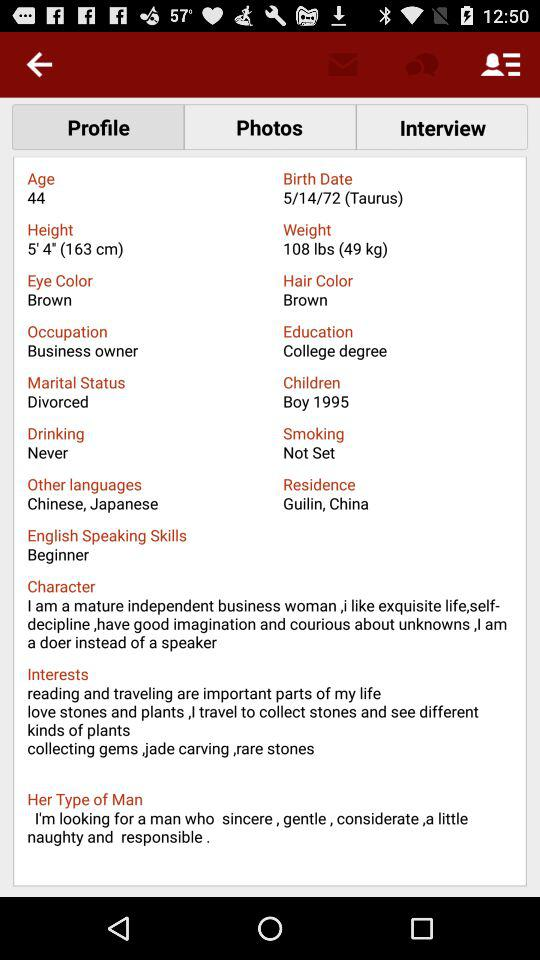What is the mentioned height? The mentioned height is 5' 4" (163 cm). 